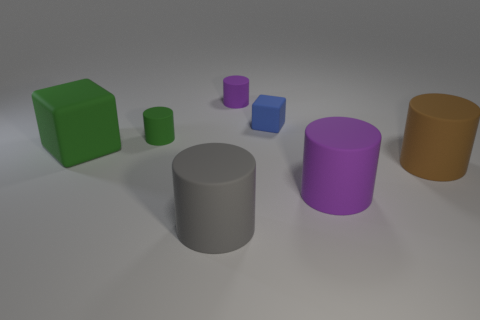There is a tiny matte thing that is behind the tiny blue cube; is its shape the same as the gray matte thing?
Ensure brevity in your answer.  Yes. Is the number of blue things in front of the large purple matte thing greater than the number of gray cylinders?
Your answer should be compact. No. Are there any other things that are the same material as the green block?
Make the answer very short. Yes. What shape is the tiny rubber thing that is the same color as the large cube?
Offer a very short reply. Cylinder. How many balls are green things or large rubber things?
Offer a very short reply. 0. What color is the big thing that is to the right of the purple matte thing that is in front of the green cube?
Offer a terse response. Brown. Does the big block have the same color as the big cylinder to the left of the small purple cylinder?
Offer a very short reply. No. There is a green cube that is the same material as the tiny purple cylinder; what size is it?
Provide a succinct answer. Large. There is a cylinder that is the same color as the big rubber block; what size is it?
Keep it short and to the point. Small. Do the large block and the tiny cube have the same color?
Make the answer very short. No. 